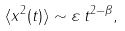Convert formula to latex. <formula><loc_0><loc_0><loc_500><loc_500>\langle x ^ { 2 } ( t ) \rangle \sim \varepsilon \, t ^ { 2 - \beta } ,</formula> 